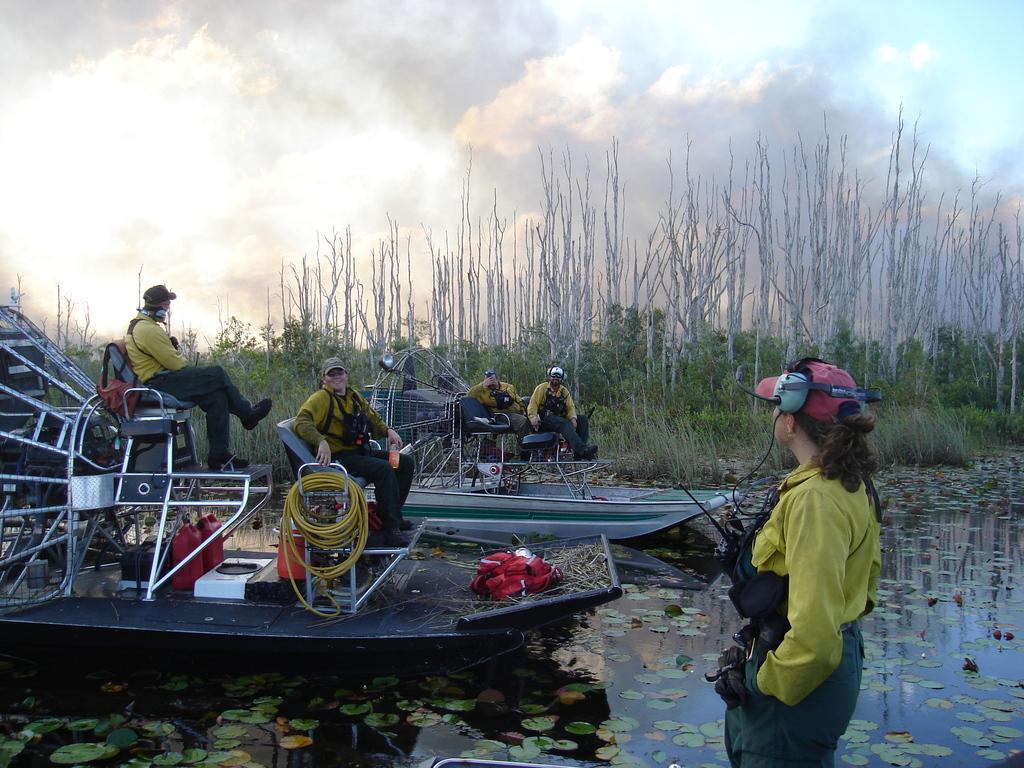Please provide a concise description of this image. On the left side of this image there is a on the water. On the boat I can see four people are sitting and there are some metal stands, ropes, bags and some more objects are placed. On the right side I can see another person standing and looking at these people. In the background there are some trees. On the top of the image I can see the sky. 